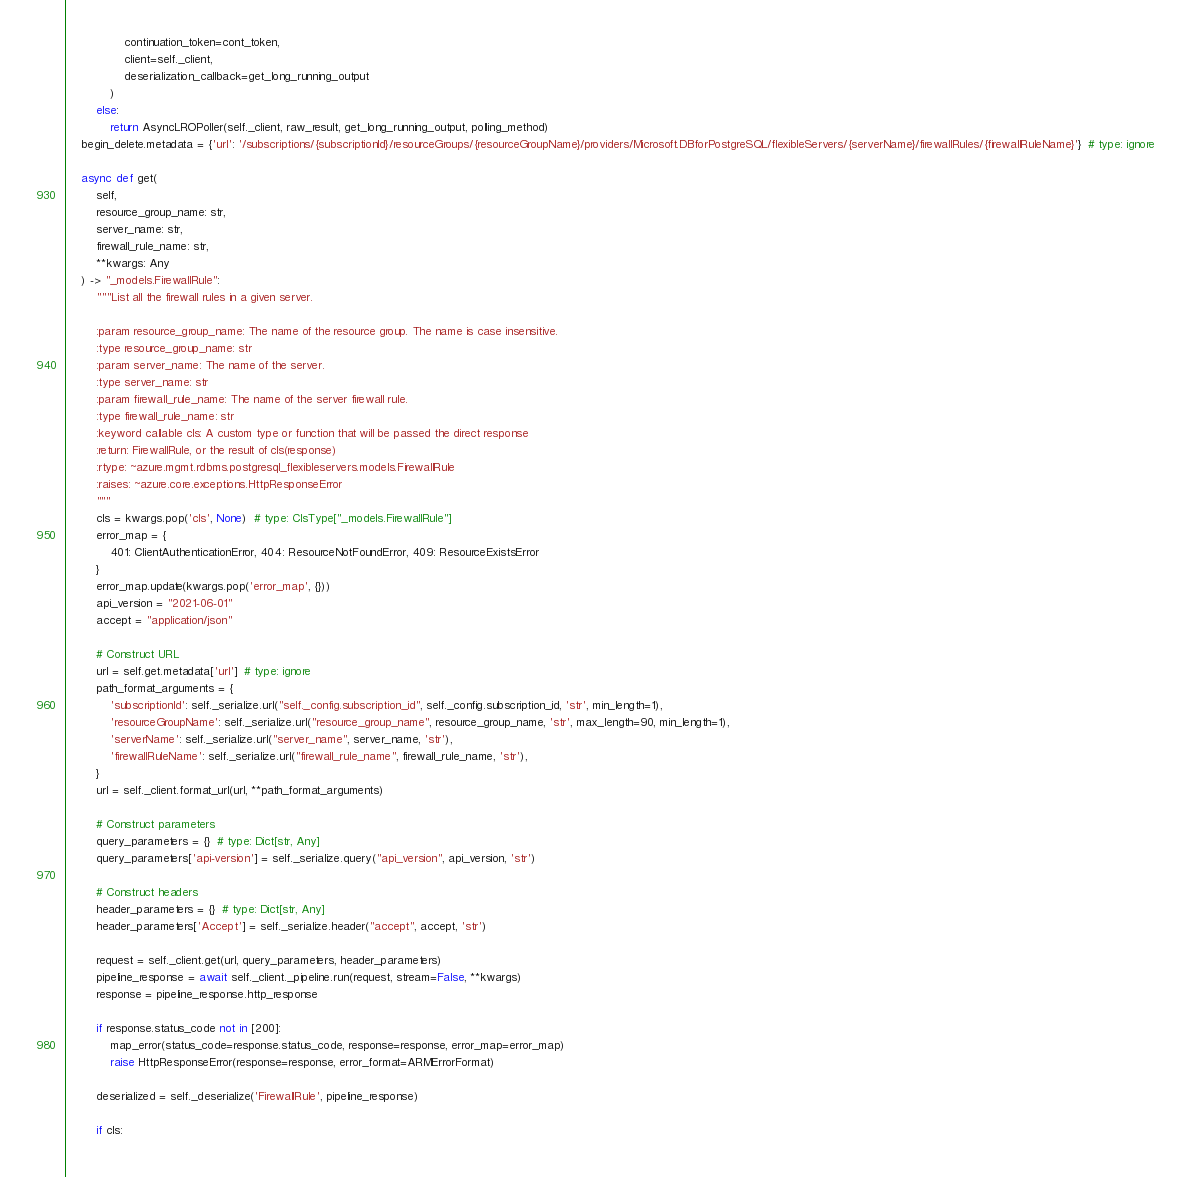<code> <loc_0><loc_0><loc_500><loc_500><_Python_>                continuation_token=cont_token,
                client=self._client,
                deserialization_callback=get_long_running_output
            )
        else:
            return AsyncLROPoller(self._client, raw_result, get_long_running_output, polling_method)
    begin_delete.metadata = {'url': '/subscriptions/{subscriptionId}/resourceGroups/{resourceGroupName}/providers/Microsoft.DBforPostgreSQL/flexibleServers/{serverName}/firewallRules/{firewallRuleName}'}  # type: ignore

    async def get(
        self,
        resource_group_name: str,
        server_name: str,
        firewall_rule_name: str,
        **kwargs: Any
    ) -> "_models.FirewallRule":
        """List all the firewall rules in a given server.

        :param resource_group_name: The name of the resource group. The name is case insensitive.
        :type resource_group_name: str
        :param server_name: The name of the server.
        :type server_name: str
        :param firewall_rule_name: The name of the server firewall rule.
        :type firewall_rule_name: str
        :keyword callable cls: A custom type or function that will be passed the direct response
        :return: FirewallRule, or the result of cls(response)
        :rtype: ~azure.mgmt.rdbms.postgresql_flexibleservers.models.FirewallRule
        :raises: ~azure.core.exceptions.HttpResponseError
        """
        cls = kwargs.pop('cls', None)  # type: ClsType["_models.FirewallRule"]
        error_map = {
            401: ClientAuthenticationError, 404: ResourceNotFoundError, 409: ResourceExistsError
        }
        error_map.update(kwargs.pop('error_map', {}))
        api_version = "2021-06-01"
        accept = "application/json"

        # Construct URL
        url = self.get.metadata['url']  # type: ignore
        path_format_arguments = {
            'subscriptionId': self._serialize.url("self._config.subscription_id", self._config.subscription_id, 'str', min_length=1),
            'resourceGroupName': self._serialize.url("resource_group_name", resource_group_name, 'str', max_length=90, min_length=1),
            'serverName': self._serialize.url("server_name", server_name, 'str'),
            'firewallRuleName': self._serialize.url("firewall_rule_name", firewall_rule_name, 'str'),
        }
        url = self._client.format_url(url, **path_format_arguments)

        # Construct parameters
        query_parameters = {}  # type: Dict[str, Any]
        query_parameters['api-version'] = self._serialize.query("api_version", api_version, 'str')

        # Construct headers
        header_parameters = {}  # type: Dict[str, Any]
        header_parameters['Accept'] = self._serialize.header("accept", accept, 'str')

        request = self._client.get(url, query_parameters, header_parameters)
        pipeline_response = await self._client._pipeline.run(request, stream=False, **kwargs)
        response = pipeline_response.http_response

        if response.status_code not in [200]:
            map_error(status_code=response.status_code, response=response, error_map=error_map)
            raise HttpResponseError(response=response, error_format=ARMErrorFormat)

        deserialized = self._deserialize('FirewallRule', pipeline_response)

        if cls:</code> 